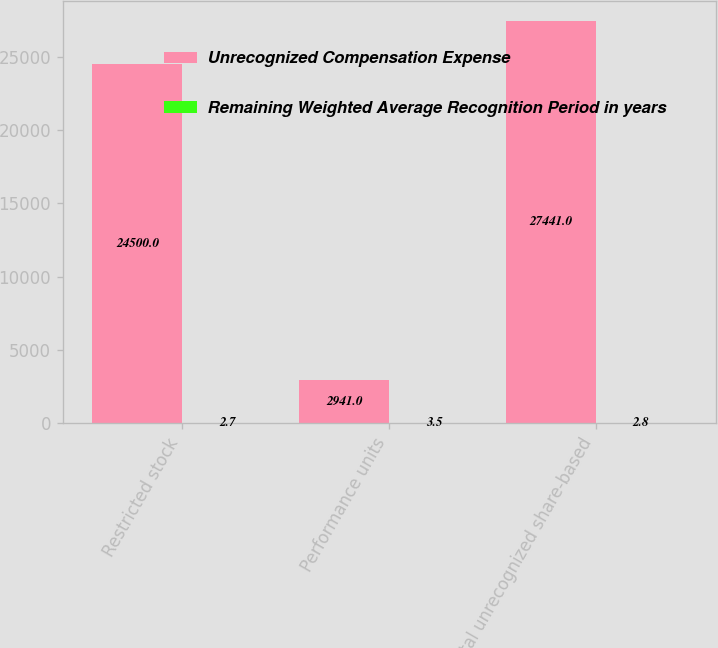<chart> <loc_0><loc_0><loc_500><loc_500><stacked_bar_chart><ecel><fcel>Restricted stock<fcel>Performance units<fcel>Total unrecognized share-based<nl><fcel>Unrecognized Compensation Expense<fcel>24500<fcel>2941<fcel>27441<nl><fcel>Remaining Weighted Average Recognition Period in years<fcel>2.7<fcel>3.5<fcel>2.8<nl></chart> 